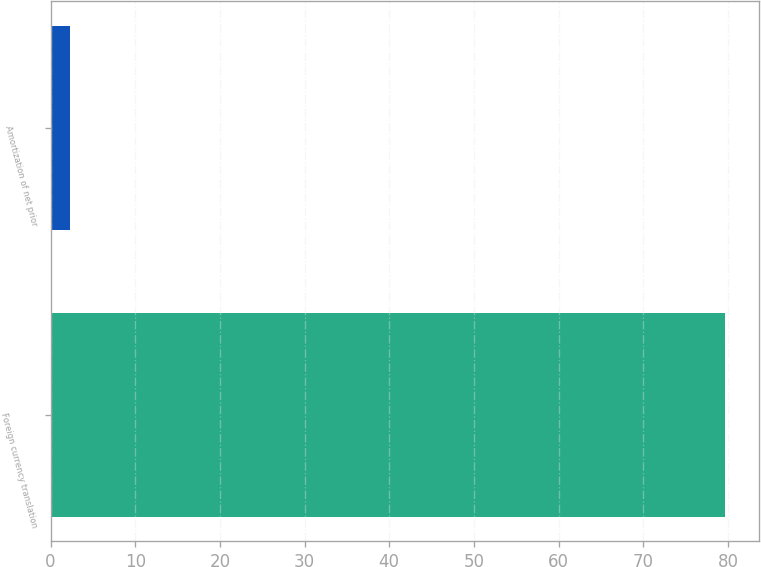Convert chart. <chart><loc_0><loc_0><loc_500><loc_500><bar_chart><fcel>Foreign currency translation<fcel>Amortization of net prior<nl><fcel>79.7<fcel>2.3<nl></chart> 